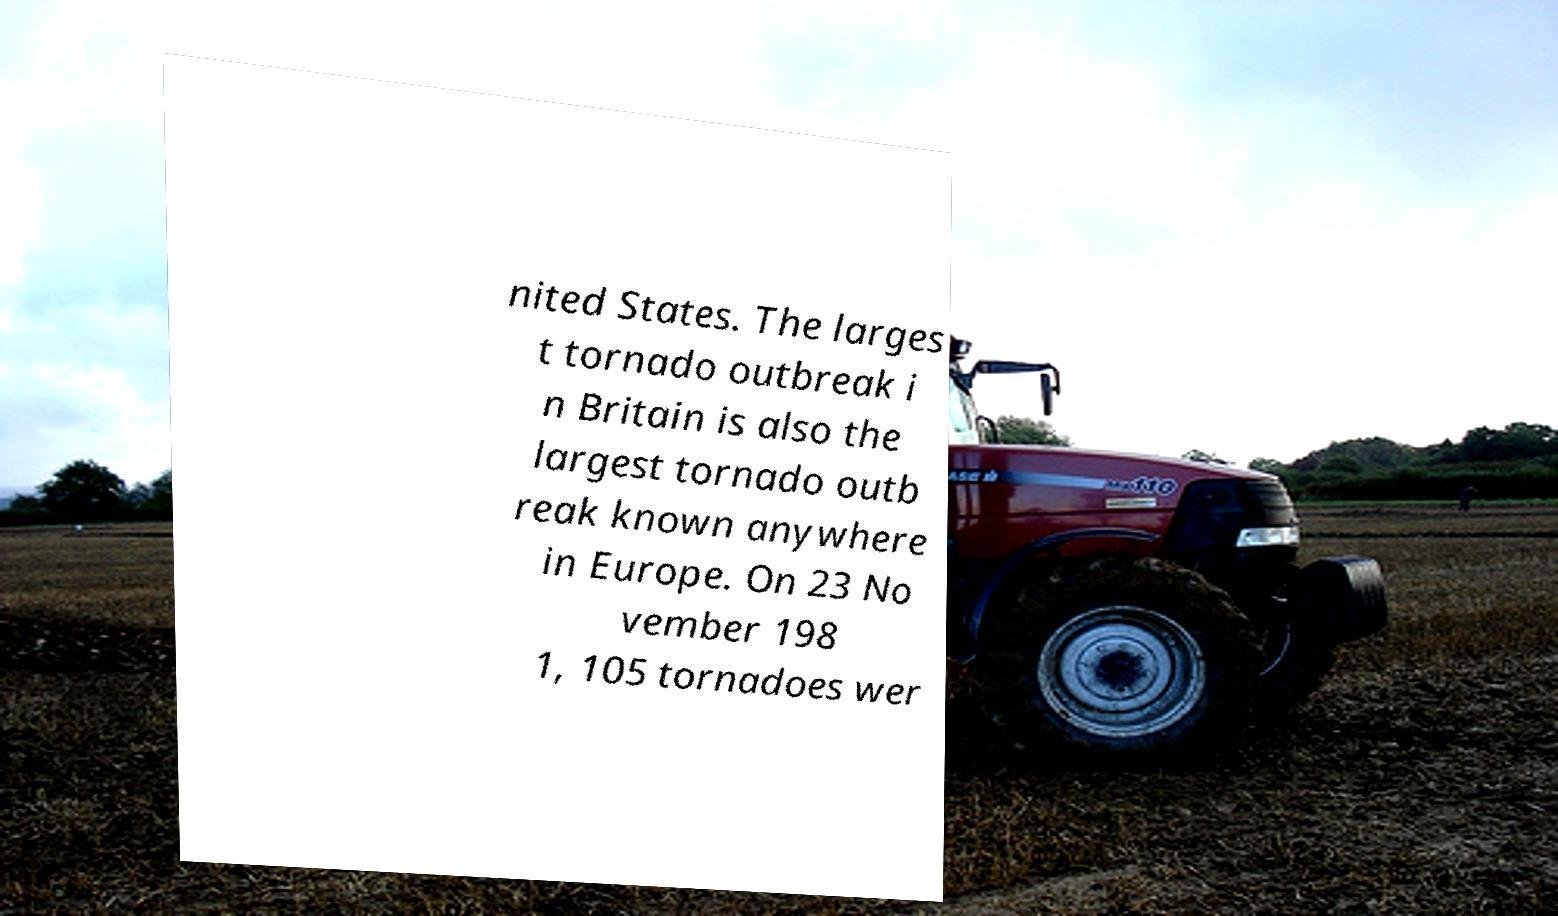Please read and relay the text visible in this image. What does it say? nited States. The larges t tornado outbreak i n Britain is also the largest tornado outb reak known anywhere in Europe. On 23 No vember 198 1, 105 tornadoes wer 